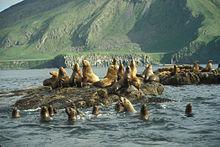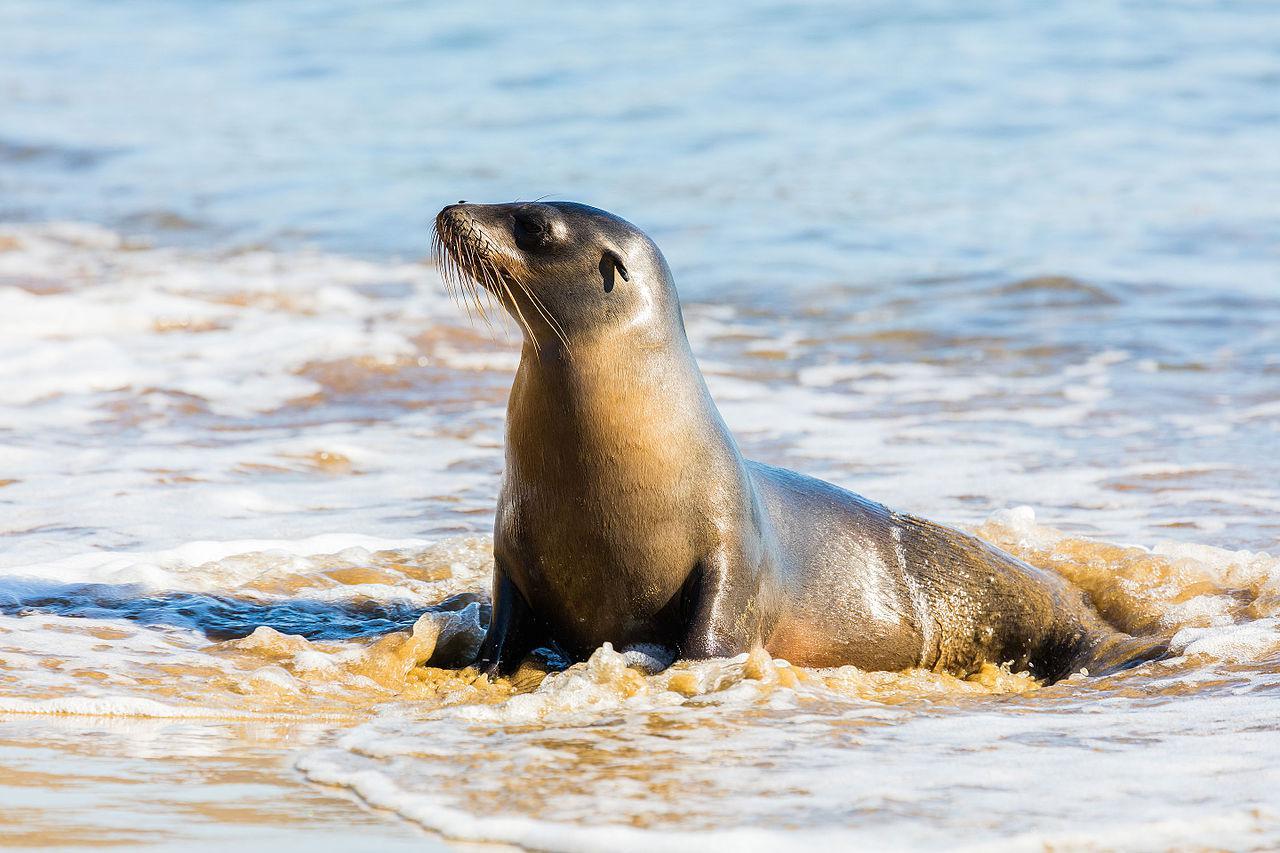The first image is the image on the left, the second image is the image on the right. Analyze the images presented: Is the assertion "One seal is in the water facing left in one image." valid? Answer yes or no. Yes. The first image is the image on the left, the second image is the image on the right. Considering the images on both sides, is "In at least one image there is a lone seal sitting in shallow water" valid? Answer yes or no. Yes. 